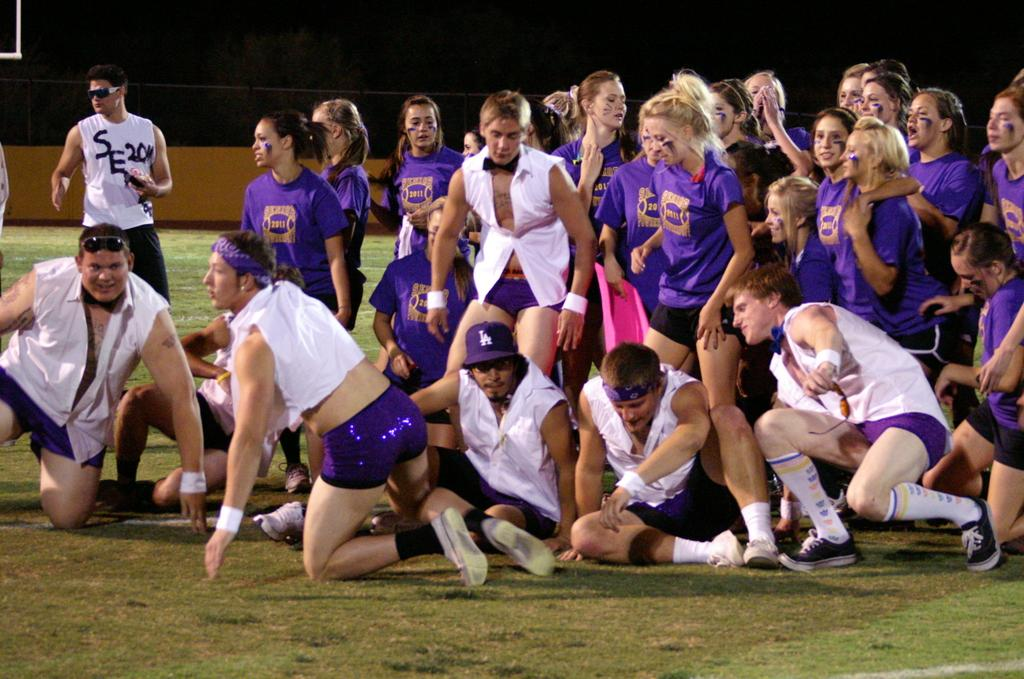What can be observed about the people in the image? There are people in the image, and some of them are wearing white and purple dresses. What are the people doing in the image? Some people are standing, and some are sitting. What is the color of the background in the image? The background color is black and brown. What type of soda is being served to the children in the image? There are no children or soda present in the image. How many hands can be seen holding the handrail in the image? There is no handrail present in the image. 